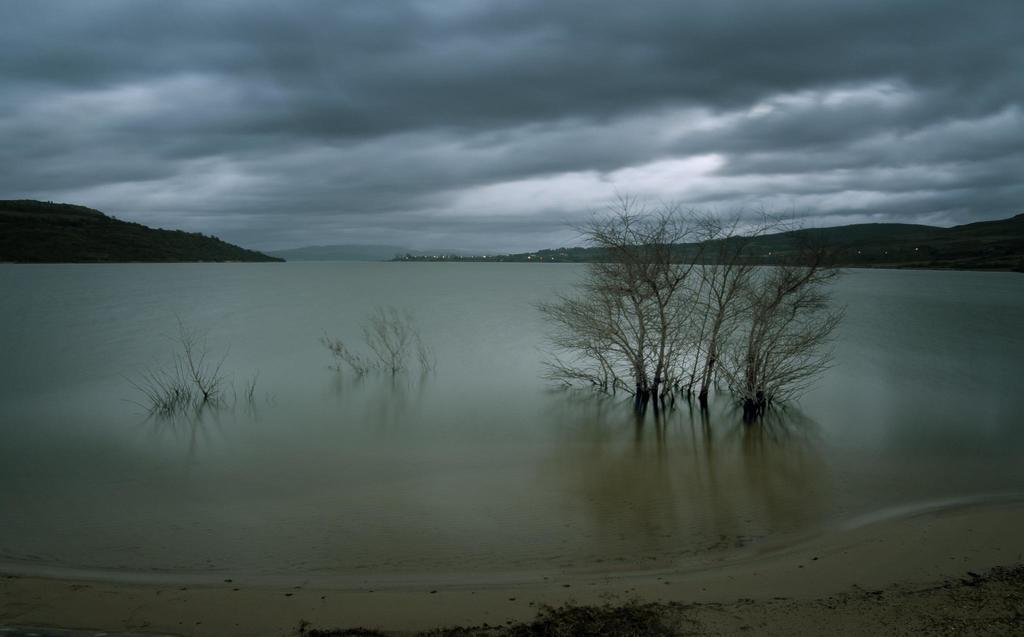Describe this image in one or two sentences. We can see trees in water. On the background we can see hills and sky with clouds. 